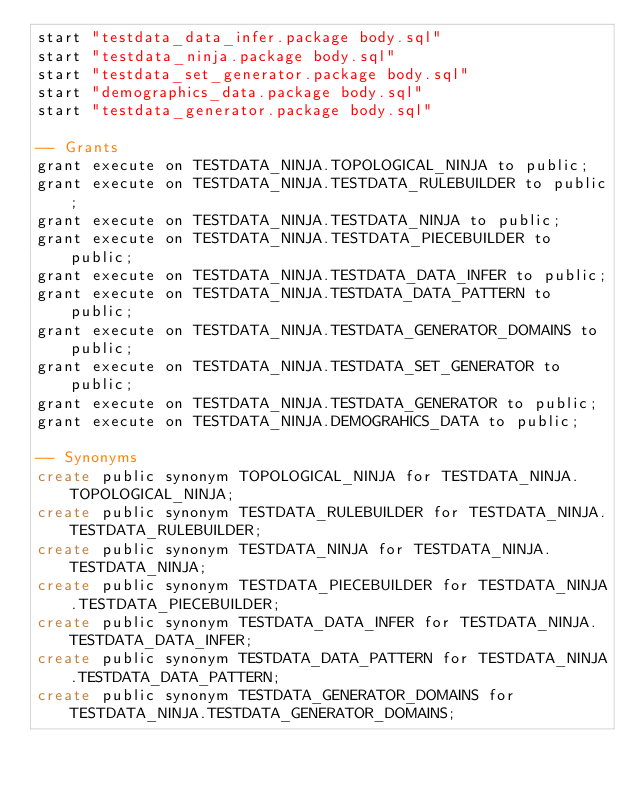Convert code to text. <code><loc_0><loc_0><loc_500><loc_500><_SQL_>start "testdata_data_infer.package body.sql"
start "testdata_ninja.package body.sql"
start "testdata_set_generator.package body.sql"
start "demographics_data.package body.sql"
start "testdata_generator.package body.sql"

-- Grants
grant execute on TESTDATA_NINJA.TOPOLOGICAL_NINJA to public;
grant execute on TESTDATA_NINJA.TESTDATA_RULEBUILDER to public;
grant execute on TESTDATA_NINJA.TESTDATA_NINJA to public;
grant execute on TESTDATA_NINJA.TESTDATA_PIECEBUILDER to public;
grant execute on TESTDATA_NINJA.TESTDATA_DATA_INFER to public;
grant execute on TESTDATA_NINJA.TESTDATA_DATA_PATTERN to public;
grant execute on TESTDATA_NINJA.TESTDATA_GENERATOR_DOMAINS to public;
grant execute on TESTDATA_NINJA.TESTDATA_SET_GENERATOR to public;
grant execute on TESTDATA_NINJA.TESTDATA_GENERATOR to public;
grant execute on TESTDATA_NINJA.DEMOGRAHICS_DATA to public;

-- Synonyms
create public synonym TOPOLOGICAL_NINJA for TESTDATA_NINJA.TOPOLOGICAL_NINJA;
create public synonym TESTDATA_RULEBUILDER for TESTDATA_NINJA.TESTDATA_RULEBUILDER;
create public synonym TESTDATA_NINJA for TESTDATA_NINJA.TESTDATA_NINJA;
create public synonym TESTDATA_PIECEBUILDER for TESTDATA_NINJA.TESTDATA_PIECEBUILDER;
create public synonym TESTDATA_DATA_INFER for TESTDATA_NINJA.TESTDATA_DATA_INFER;
create public synonym TESTDATA_DATA_PATTERN for TESTDATA_NINJA.TESTDATA_DATA_PATTERN;
create public synonym TESTDATA_GENERATOR_DOMAINS for TESTDATA_NINJA.TESTDATA_GENERATOR_DOMAINS;</code> 